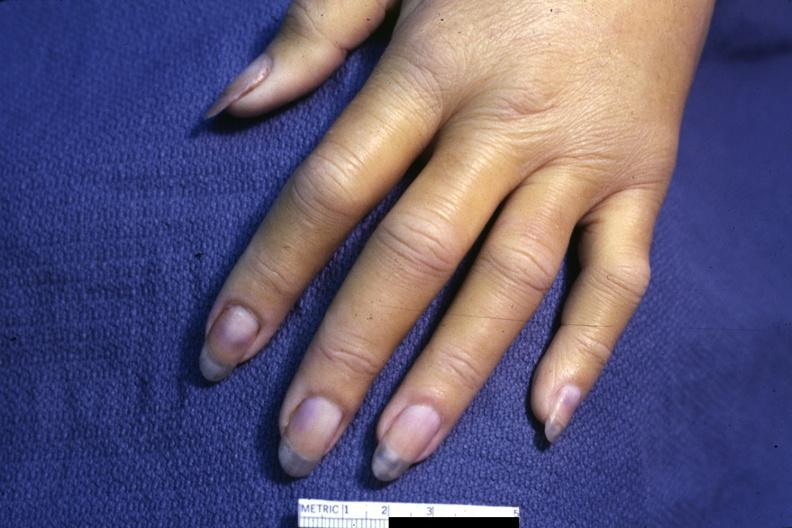re extremities present?
Answer the question using a single word or phrase. Yes 